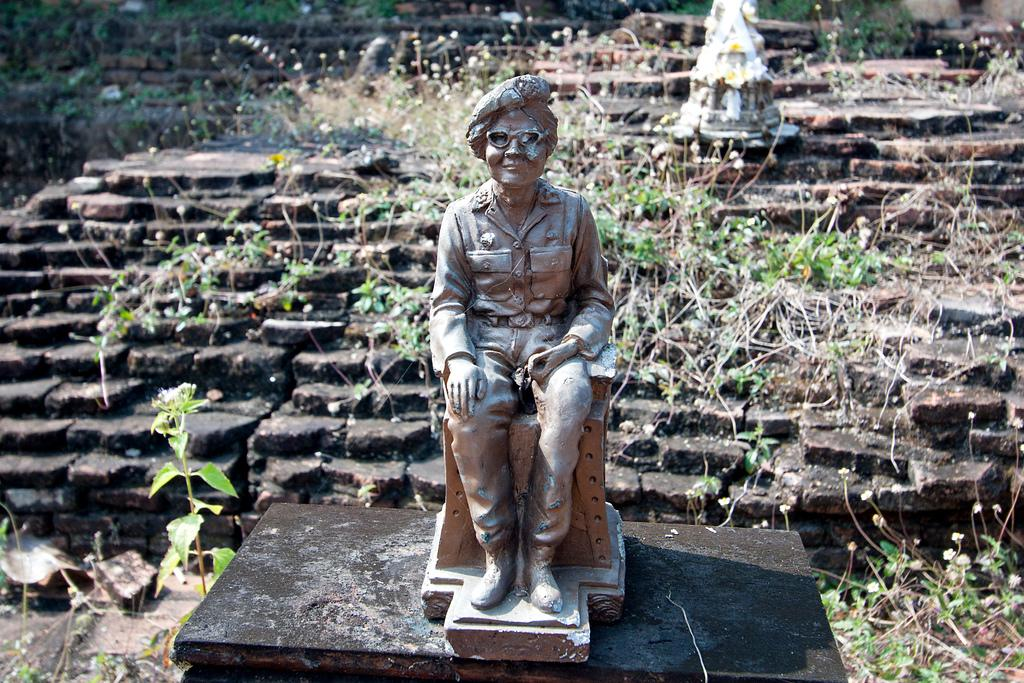What is the main subject in the center of the image? There is a statue in the center of the image. What architectural feature can be seen in the background of the image? There are steps in the background of the image. What type of natural elements are present in the image? Dry leaves and plants are present in the image. What type of stew is being served on the beds in the image? There is no stew or beds present in the image; it features a statue, steps, dry leaves, and plants. 